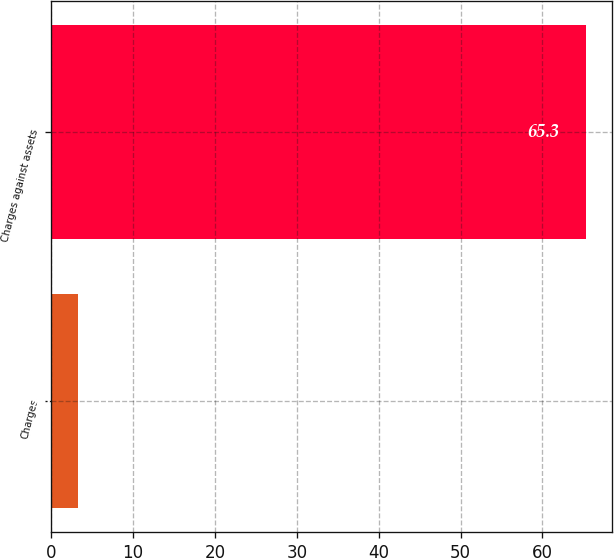<chart> <loc_0><loc_0><loc_500><loc_500><bar_chart><fcel>Charges<fcel>Charges against assets<nl><fcel>3.3<fcel>65.3<nl></chart> 